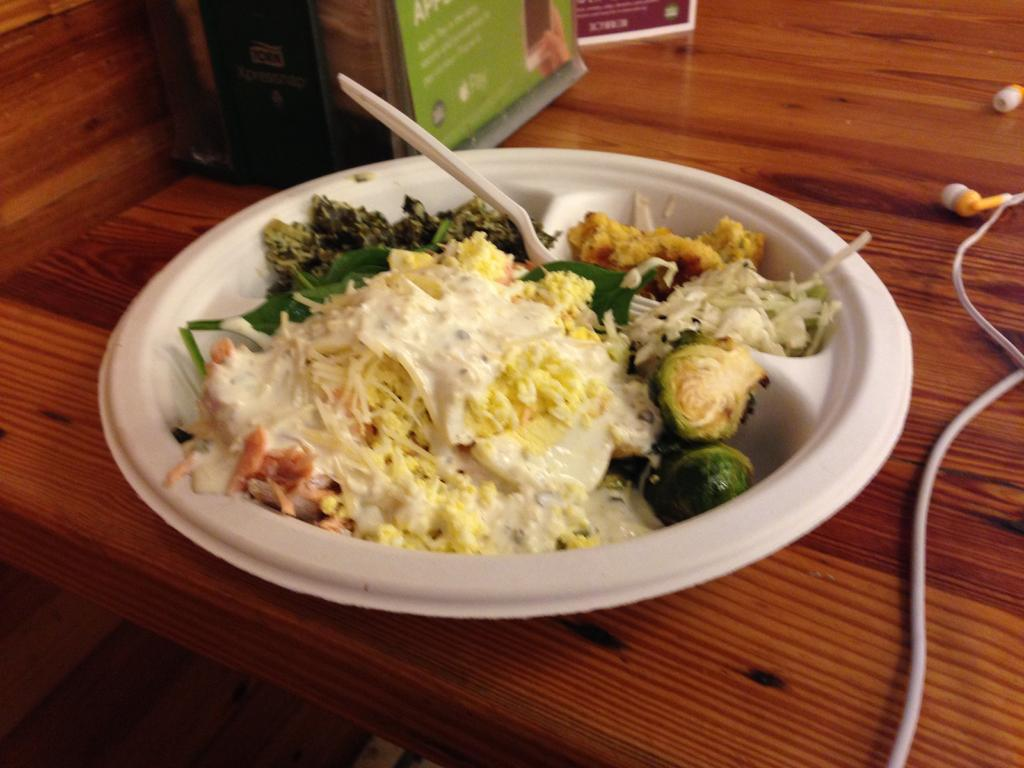What is in the bowl that is visible in the image? There is an edible in the bowl. What utensil is placed in the bowl? There is a fork placed in the bowl. What other objects can be seen beside the bowl? The image does not provide information about other objects beside the bowl. Can you see any fangs in the image? There are no fangs present in the image. What happens when the edible bursts in the image? The image does not depict the edible bursting, so we cannot answer this question. 